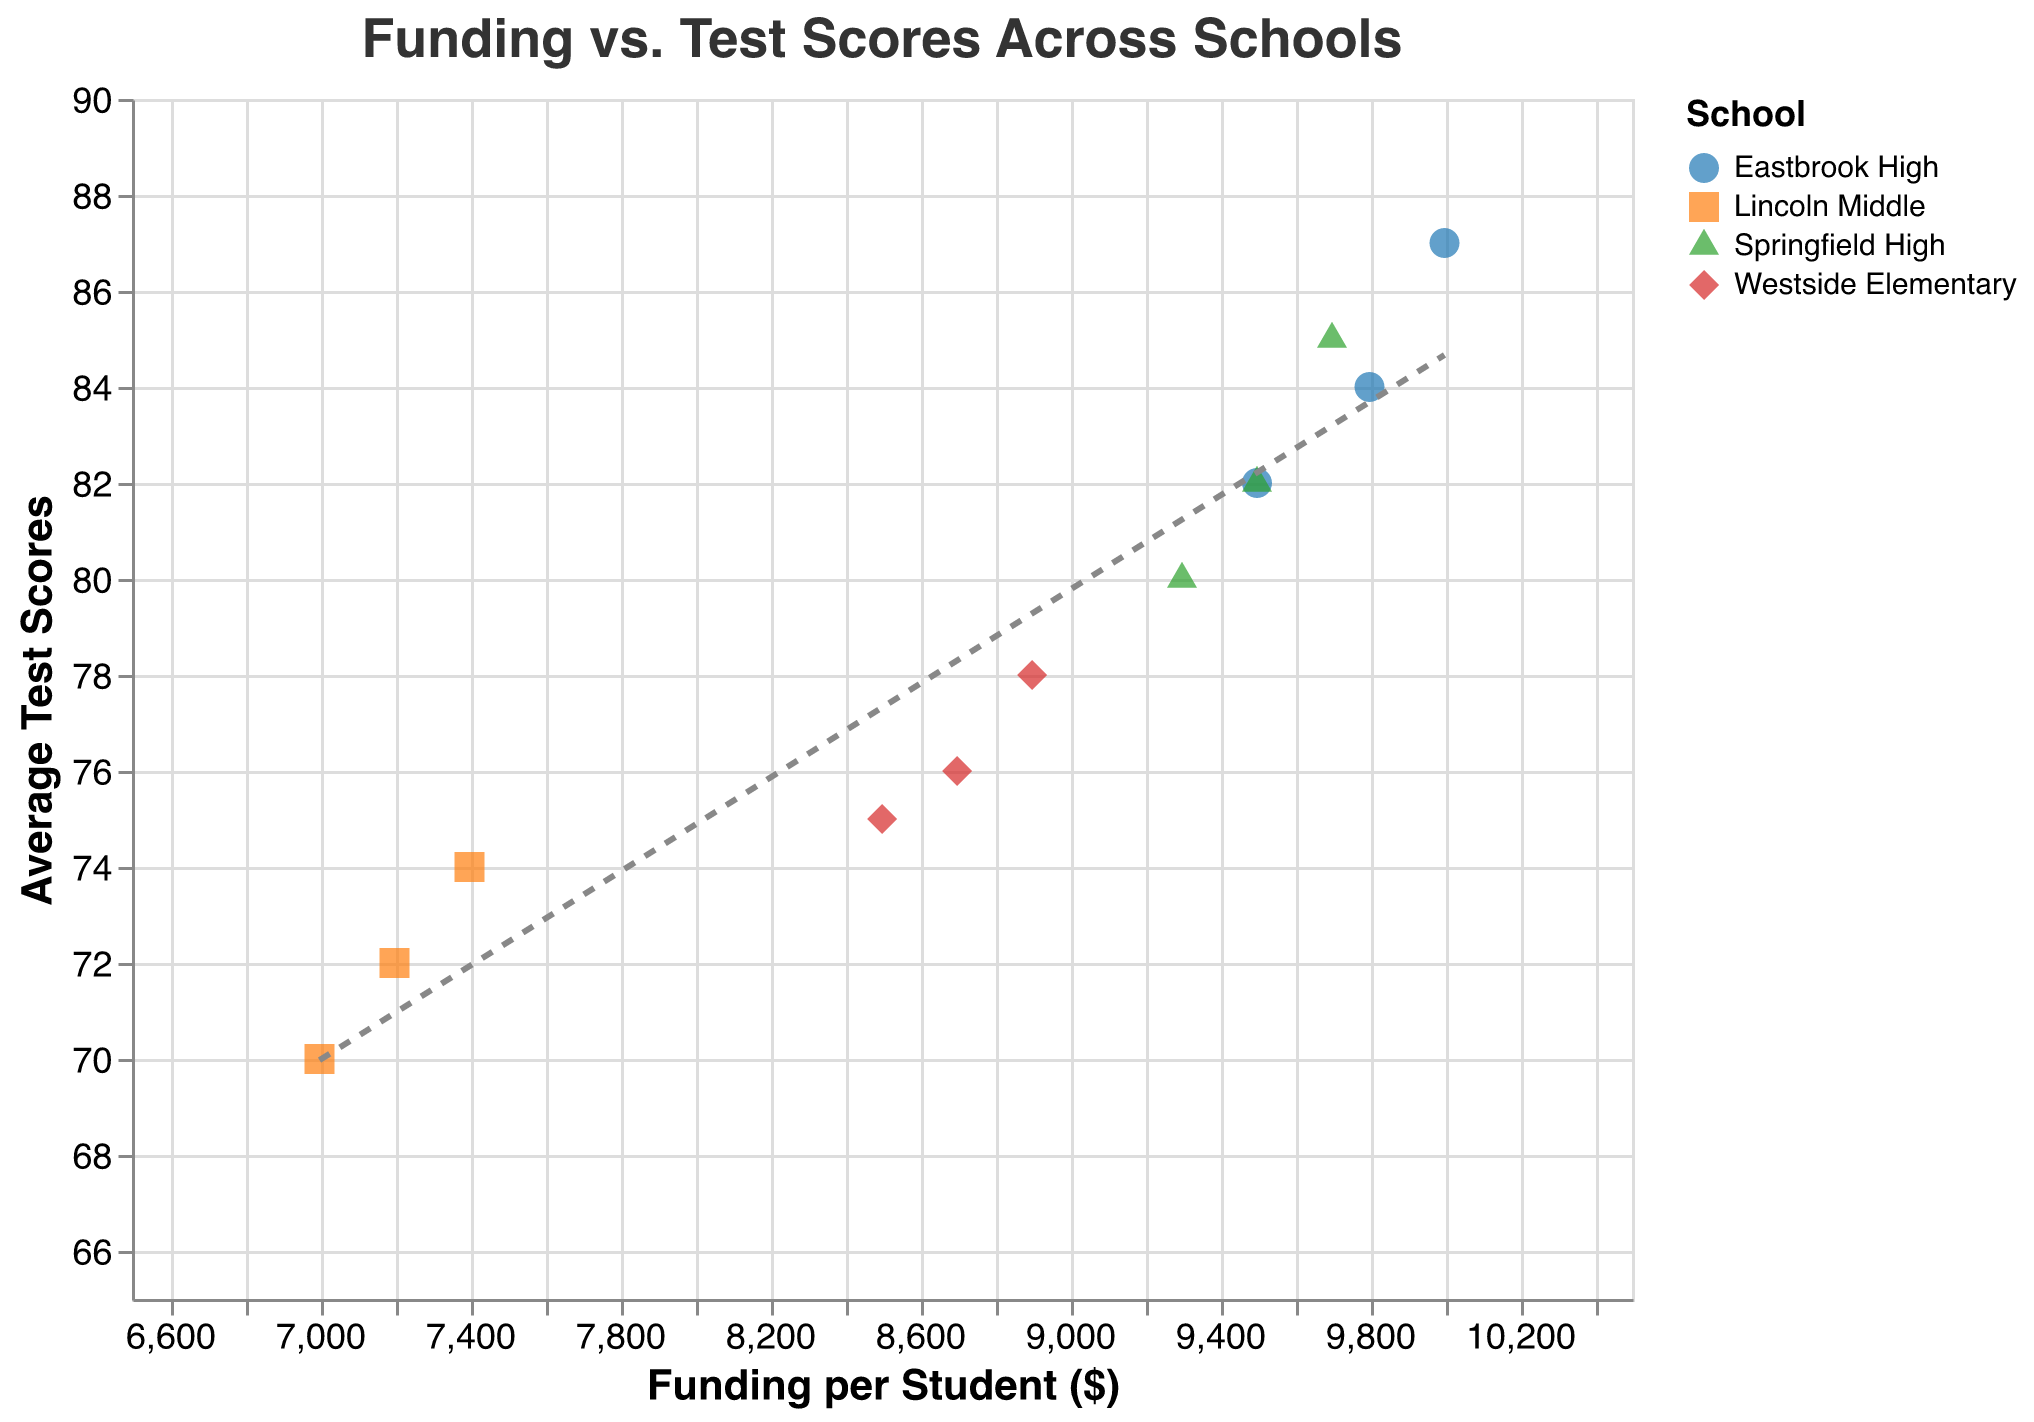What is the title of the figure? The title is located at the top of the figure and usually summarizes what the plot represents.
Answer: "Funding vs. Test Scores Across Schools" Which school has the highest funding per student in 2012? The year 2012 is specified, and the data points for each school in 2012 can be checked to see which has the highest funding value on the x-axis.
Answer: Eastbrook High What is the range of average test scores shown in the figure? The y-axis represents average test scores, and the values range from the lowest to the highest point marked on this axis.
Answer: 65 to 90 Which school had the highest increase in average test scores from 2010 to 2012? By comparing the test scores for each school from 2010 to 2012, one can calculate the difference and see which school has the highest positive change.
Answer: Eastbrook High What's the relationship between funding per student and average test scores as indicated by the trend line? The trend line shows the overall direction and relationship between the funding per student and the average test scores. The slope of the trend line will indicate whether the relationship is positive, negative, or neutral.
Answer: Positive Which data point represents Lincoln Middle in 2011 and what is its average test score? Identify the point for Lincoln Middle in the year 2011 by looking at the tooltip or matching the coordinates for the year and school, and read the average test scores value on the y-axis.
Answer: 72 Are the test scores for Springfield High above or below the overall trend line? By locating the points representing Springfield High and comparing them to the position of the trend line, you can determine their position relative to the trend line.
Answer: Above How does the difference in resource allocation per student from 2010 to 2012 compare between Westside Elementary and Springfield High? Subtract the 2010 value from the 2012 value for both schools to find the difference. Then, compare the differences.
Answer: Both schools have an increase of 300 Which school consistently stayed above the overall trend line from 2010 to 2012? Look at each school's points for the different years and compare their position relative to the trend line to see if any school’s data points are consistently above it.
Answer: Eastbrook High 